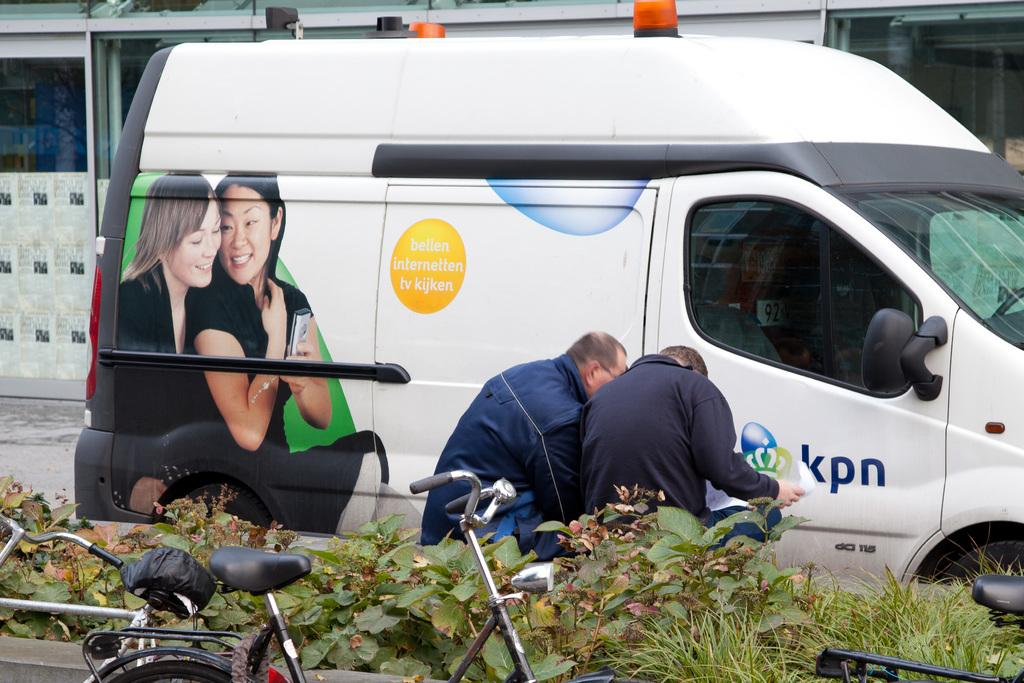<image>
Create a compact narrative representing the image presented. Men standing in front of a white van with the letters KPN on it. 